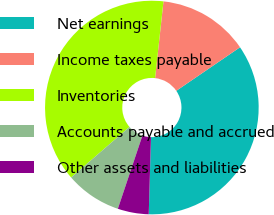Convert chart to OTSL. <chart><loc_0><loc_0><loc_500><loc_500><pie_chart><fcel>Net earnings<fcel>Income taxes payable<fcel>Inventories<fcel>Accounts payable and accrued<fcel>Other assets and liabilities<nl><fcel>35.01%<fcel>13.72%<fcel>38.1%<fcel>8.48%<fcel>4.69%<nl></chart> 